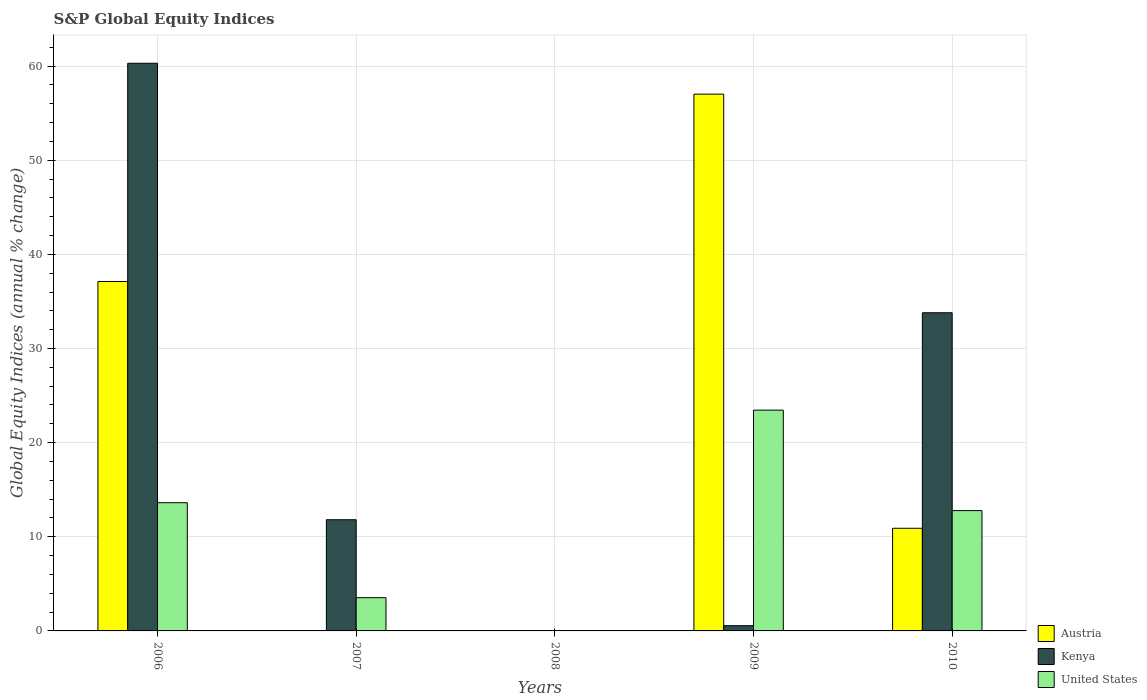How many different coloured bars are there?
Your response must be concise. 3. Are the number of bars per tick equal to the number of legend labels?
Offer a very short reply. No. What is the label of the 2nd group of bars from the left?
Provide a short and direct response. 2007. What is the global equity indices in United States in 2009?
Make the answer very short. 23.45. Across all years, what is the maximum global equity indices in United States?
Offer a very short reply. 23.45. Across all years, what is the minimum global equity indices in Austria?
Offer a terse response. 0. In which year was the global equity indices in Kenya maximum?
Offer a terse response. 2006. What is the total global equity indices in Austria in the graph?
Your answer should be very brief. 105.05. What is the difference between the global equity indices in Austria in 2009 and that in 2010?
Keep it short and to the point. 46.12. What is the difference between the global equity indices in United States in 2009 and the global equity indices in Austria in 2006?
Provide a succinct answer. -13.67. What is the average global equity indices in Kenya per year?
Your answer should be very brief. 21.29. In the year 2009, what is the difference between the global equity indices in Kenya and global equity indices in Austria?
Ensure brevity in your answer.  -56.47. In how many years, is the global equity indices in Austria greater than 30 %?
Give a very brief answer. 2. What is the ratio of the global equity indices in Austria in 2009 to that in 2010?
Provide a succinct answer. 5.23. Is the global equity indices in Kenya in 2006 less than that in 2009?
Provide a succinct answer. No. What is the difference between the highest and the second highest global equity indices in United States?
Provide a succinct answer. 9.83. What is the difference between the highest and the lowest global equity indices in Kenya?
Ensure brevity in your answer.  60.3. In how many years, is the global equity indices in United States greater than the average global equity indices in United States taken over all years?
Offer a very short reply. 3. Is the sum of the global equity indices in Kenya in 2009 and 2010 greater than the maximum global equity indices in Austria across all years?
Your response must be concise. No. Is it the case that in every year, the sum of the global equity indices in Austria and global equity indices in United States is greater than the global equity indices in Kenya?
Make the answer very short. No. How many bars are there?
Provide a short and direct response. 11. Are all the bars in the graph horizontal?
Provide a short and direct response. No. Does the graph contain any zero values?
Keep it short and to the point. Yes. Does the graph contain grids?
Keep it short and to the point. Yes. How many legend labels are there?
Make the answer very short. 3. How are the legend labels stacked?
Your answer should be compact. Vertical. What is the title of the graph?
Your response must be concise. S&P Global Equity Indices. What is the label or title of the X-axis?
Make the answer very short. Years. What is the label or title of the Y-axis?
Your response must be concise. Global Equity Indices (annual % change). What is the Global Equity Indices (annual % change) in Austria in 2006?
Offer a very short reply. 37.12. What is the Global Equity Indices (annual % change) in Kenya in 2006?
Provide a short and direct response. 60.3. What is the Global Equity Indices (annual % change) of United States in 2006?
Give a very brief answer. 13.62. What is the Global Equity Indices (annual % change) of Austria in 2007?
Provide a succinct answer. 0. What is the Global Equity Indices (annual % change) in Kenya in 2007?
Make the answer very short. 11.81. What is the Global Equity Indices (annual % change) of United States in 2007?
Offer a terse response. 3.53. What is the Global Equity Indices (annual % change) of Kenya in 2008?
Your response must be concise. 0. What is the Global Equity Indices (annual % change) of United States in 2008?
Your answer should be compact. 0. What is the Global Equity Indices (annual % change) of Austria in 2009?
Your answer should be very brief. 57.02. What is the Global Equity Indices (annual % change) in Kenya in 2009?
Offer a terse response. 0.56. What is the Global Equity Indices (annual % change) in United States in 2009?
Offer a terse response. 23.45. What is the Global Equity Indices (annual % change) in Austria in 2010?
Keep it short and to the point. 10.9. What is the Global Equity Indices (annual % change) in Kenya in 2010?
Provide a succinct answer. 33.8. What is the Global Equity Indices (annual % change) in United States in 2010?
Your answer should be very brief. 12.78. Across all years, what is the maximum Global Equity Indices (annual % change) of Austria?
Your answer should be very brief. 57.02. Across all years, what is the maximum Global Equity Indices (annual % change) of Kenya?
Offer a very short reply. 60.3. Across all years, what is the maximum Global Equity Indices (annual % change) of United States?
Give a very brief answer. 23.45. Across all years, what is the minimum Global Equity Indices (annual % change) in Austria?
Your answer should be very brief. 0. Across all years, what is the minimum Global Equity Indices (annual % change) of Kenya?
Ensure brevity in your answer.  0. Across all years, what is the minimum Global Equity Indices (annual % change) of United States?
Offer a very short reply. 0. What is the total Global Equity Indices (annual % change) of Austria in the graph?
Your response must be concise. 105.05. What is the total Global Equity Indices (annual % change) of Kenya in the graph?
Your answer should be very brief. 106.47. What is the total Global Equity Indices (annual % change) in United States in the graph?
Provide a succinct answer. 53.38. What is the difference between the Global Equity Indices (annual % change) in Kenya in 2006 and that in 2007?
Offer a terse response. 48.49. What is the difference between the Global Equity Indices (annual % change) in United States in 2006 and that in 2007?
Your response must be concise. 10.09. What is the difference between the Global Equity Indices (annual % change) of Austria in 2006 and that in 2009?
Your answer should be compact. -19.9. What is the difference between the Global Equity Indices (annual % change) in Kenya in 2006 and that in 2009?
Make the answer very short. 59.75. What is the difference between the Global Equity Indices (annual % change) in United States in 2006 and that in 2009?
Your answer should be compact. -9.83. What is the difference between the Global Equity Indices (annual % change) in Austria in 2006 and that in 2010?
Give a very brief answer. 26.22. What is the difference between the Global Equity Indices (annual % change) of Kenya in 2006 and that in 2010?
Offer a terse response. 26.5. What is the difference between the Global Equity Indices (annual % change) in United States in 2006 and that in 2010?
Offer a very short reply. 0.84. What is the difference between the Global Equity Indices (annual % change) in Kenya in 2007 and that in 2009?
Keep it short and to the point. 11.26. What is the difference between the Global Equity Indices (annual % change) of United States in 2007 and that in 2009?
Provide a short and direct response. -19.92. What is the difference between the Global Equity Indices (annual % change) of Kenya in 2007 and that in 2010?
Ensure brevity in your answer.  -21.99. What is the difference between the Global Equity Indices (annual % change) of United States in 2007 and that in 2010?
Ensure brevity in your answer.  -9.25. What is the difference between the Global Equity Indices (annual % change) in Austria in 2009 and that in 2010?
Ensure brevity in your answer.  46.12. What is the difference between the Global Equity Indices (annual % change) in Kenya in 2009 and that in 2010?
Make the answer very short. -33.24. What is the difference between the Global Equity Indices (annual % change) of United States in 2009 and that in 2010?
Make the answer very short. 10.67. What is the difference between the Global Equity Indices (annual % change) in Austria in 2006 and the Global Equity Indices (annual % change) in Kenya in 2007?
Ensure brevity in your answer.  25.31. What is the difference between the Global Equity Indices (annual % change) in Austria in 2006 and the Global Equity Indices (annual % change) in United States in 2007?
Ensure brevity in your answer.  33.59. What is the difference between the Global Equity Indices (annual % change) in Kenya in 2006 and the Global Equity Indices (annual % change) in United States in 2007?
Provide a short and direct response. 56.77. What is the difference between the Global Equity Indices (annual % change) in Austria in 2006 and the Global Equity Indices (annual % change) in Kenya in 2009?
Provide a succinct answer. 36.57. What is the difference between the Global Equity Indices (annual % change) of Austria in 2006 and the Global Equity Indices (annual % change) of United States in 2009?
Ensure brevity in your answer.  13.67. What is the difference between the Global Equity Indices (annual % change) in Kenya in 2006 and the Global Equity Indices (annual % change) in United States in 2009?
Offer a terse response. 36.85. What is the difference between the Global Equity Indices (annual % change) in Austria in 2006 and the Global Equity Indices (annual % change) in Kenya in 2010?
Provide a succinct answer. 3.32. What is the difference between the Global Equity Indices (annual % change) in Austria in 2006 and the Global Equity Indices (annual % change) in United States in 2010?
Make the answer very short. 24.34. What is the difference between the Global Equity Indices (annual % change) of Kenya in 2006 and the Global Equity Indices (annual % change) of United States in 2010?
Offer a very short reply. 47.52. What is the difference between the Global Equity Indices (annual % change) in Kenya in 2007 and the Global Equity Indices (annual % change) in United States in 2009?
Your response must be concise. -11.64. What is the difference between the Global Equity Indices (annual % change) in Kenya in 2007 and the Global Equity Indices (annual % change) in United States in 2010?
Ensure brevity in your answer.  -0.97. What is the difference between the Global Equity Indices (annual % change) of Austria in 2009 and the Global Equity Indices (annual % change) of Kenya in 2010?
Your response must be concise. 23.22. What is the difference between the Global Equity Indices (annual % change) of Austria in 2009 and the Global Equity Indices (annual % change) of United States in 2010?
Offer a very short reply. 44.24. What is the difference between the Global Equity Indices (annual % change) in Kenya in 2009 and the Global Equity Indices (annual % change) in United States in 2010?
Your answer should be very brief. -12.23. What is the average Global Equity Indices (annual % change) in Austria per year?
Keep it short and to the point. 21.01. What is the average Global Equity Indices (annual % change) in Kenya per year?
Ensure brevity in your answer.  21.29. What is the average Global Equity Indices (annual % change) in United States per year?
Offer a very short reply. 10.68. In the year 2006, what is the difference between the Global Equity Indices (annual % change) of Austria and Global Equity Indices (annual % change) of Kenya?
Keep it short and to the point. -23.18. In the year 2006, what is the difference between the Global Equity Indices (annual % change) of Austria and Global Equity Indices (annual % change) of United States?
Give a very brief answer. 23.5. In the year 2006, what is the difference between the Global Equity Indices (annual % change) of Kenya and Global Equity Indices (annual % change) of United States?
Your answer should be very brief. 46.68. In the year 2007, what is the difference between the Global Equity Indices (annual % change) in Kenya and Global Equity Indices (annual % change) in United States?
Your answer should be compact. 8.28. In the year 2009, what is the difference between the Global Equity Indices (annual % change) in Austria and Global Equity Indices (annual % change) in Kenya?
Your response must be concise. 56.47. In the year 2009, what is the difference between the Global Equity Indices (annual % change) in Austria and Global Equity Indices (annual % change) in United States?
Make the answer very short. 33.57. In the year 2009, what is the difference between the Global Equity Indices (annual % change) in Kenya and Global Equity Indices (annual % change) in United States?
Make the answer very short. -22.9. In the year 2010, what is the difference between the Global Equity Indices (annual % change) in Austria and Global Equity Indices (annual % change) in Kenya?
Your answer should be compact. -22.89. In the year 2010, what is the difference between the Global Equity Indices (annual % change) of Austria and Global Equity Indices (annual % change) of United States?
Your response must be concise. -1.88. In the year 2010, what is the difference between the Global Equity Indices (annual % change) in Kenya and Global Equity Indices (annual % change) in United States?
Make the answer very short. 21.02. What is the ratio of the Global Equity Indices (annual % change) in Kenya in 2006 to that in 2007?
Give a very brief answer. 5.1. What is the ratio of the Global Equity Indices (annual % change) of United States in 2006 to that in 2007?
Your response must be concise. 3.86. What is the ratio of the Global Equity Indices (annual % change) in Austria in 2006 to that in 2009?
Make the answer very short. 0.65. What is the ratio of the Global Equity Indices (annual % change) of Kenya in 2006 to that in 2009?
Keep it short and to the point. 108.55. What is the ratio of the Global Equity Indices (annual % change) of United States in 2006 to that in 2009?
Offer a very short reply. 0.58. What is the ratio of the Global Equity Indices (annual % change) in Austria in 2006 to that in 2010?
Your response must be concise. 3.4. What is the ratio of the Global Equity Indices (annual % change) of Kenya in 2006 to that in 2010?
Your answer should be compact. 1.78. What is the ratio of the Global Equity Indices (annual % change) in United States in 2006 to that in 2010?
Your response must be concise. 1.07. What is the ratio of the Global Equity Indices (annual % change) of Kenya in 2007 to that in 2009?
Make the answer very short. 21.26. What is the ratio of the Global Equity Indices (annual % change) in United States in 2007 to that in 2009?
Offer a terse response. 0.15. What is the ratio of the Global Equity Indices (annual % change) in Kenya in 2007 to that in 2010?
Your answer should be compact. 0.35. What is the ratio of the Global Equity Indices (annual % change) in United States in 2007 to that in 2010?
Your answer should be compact. 0.28. What is the ratio of the Global Equity Indices (annual % change) in Austria in 2009 to that in 2010?
Make the answer very short. 5.23. What is the ratio of the Global Equity Indices (annual % change) in Kenya in 2009 to that in 2010?
Offer a very short reply. 0.02. What is the ratio of the Global Equity Indices (annual % change) in United States in 2009 to that in 2010?
Give a very brief answer. 1.83. What is the difference between the highest and the second highest Global Equity Indices (annual % change) in Austria?
Your response must be concise. 19.9. What is the difference between the highest and the second highest Global Equity Indices (annual % change) in Kenya?
Keep it short and to the point. 26.5. What is the difference between the highest and the second highest Global Equity Indices (annual % change) of United States?
Your response must be concise. 9.83. What is the difference between the highest and the lowest Global Equity Indices (annual % change) of Austria?
Offer a terse response. 57.02. What is the difference between the highest and the lowest Global Equity Indices (annual % change) in Kenya?
Give a very brief answer. 60.3. What is the difference between the highest and the lowest Global Equity Indices (annual % change) in United States?
Your answer should be very brief. 23.45. 